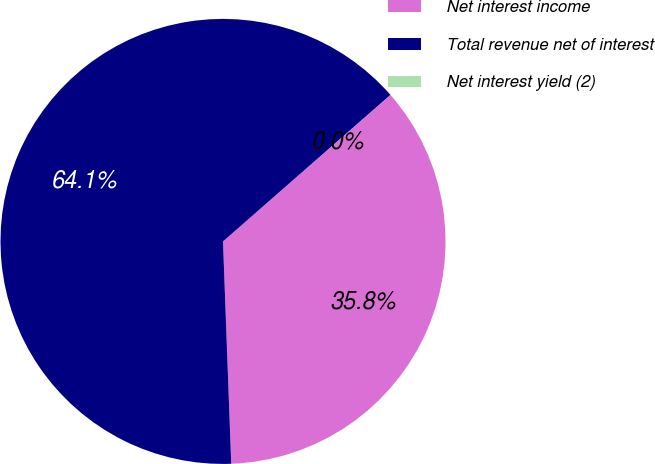<chart> <loc_0><loc_0><loc_500><loc_500><pie_chart><fcel>Net interest income<fcel>Total revenue net of interest<fcel>Net interest yield (2)<nl><fcel>35.84%<fcel>64.15%<fcel>0.01%<nl></chart> 